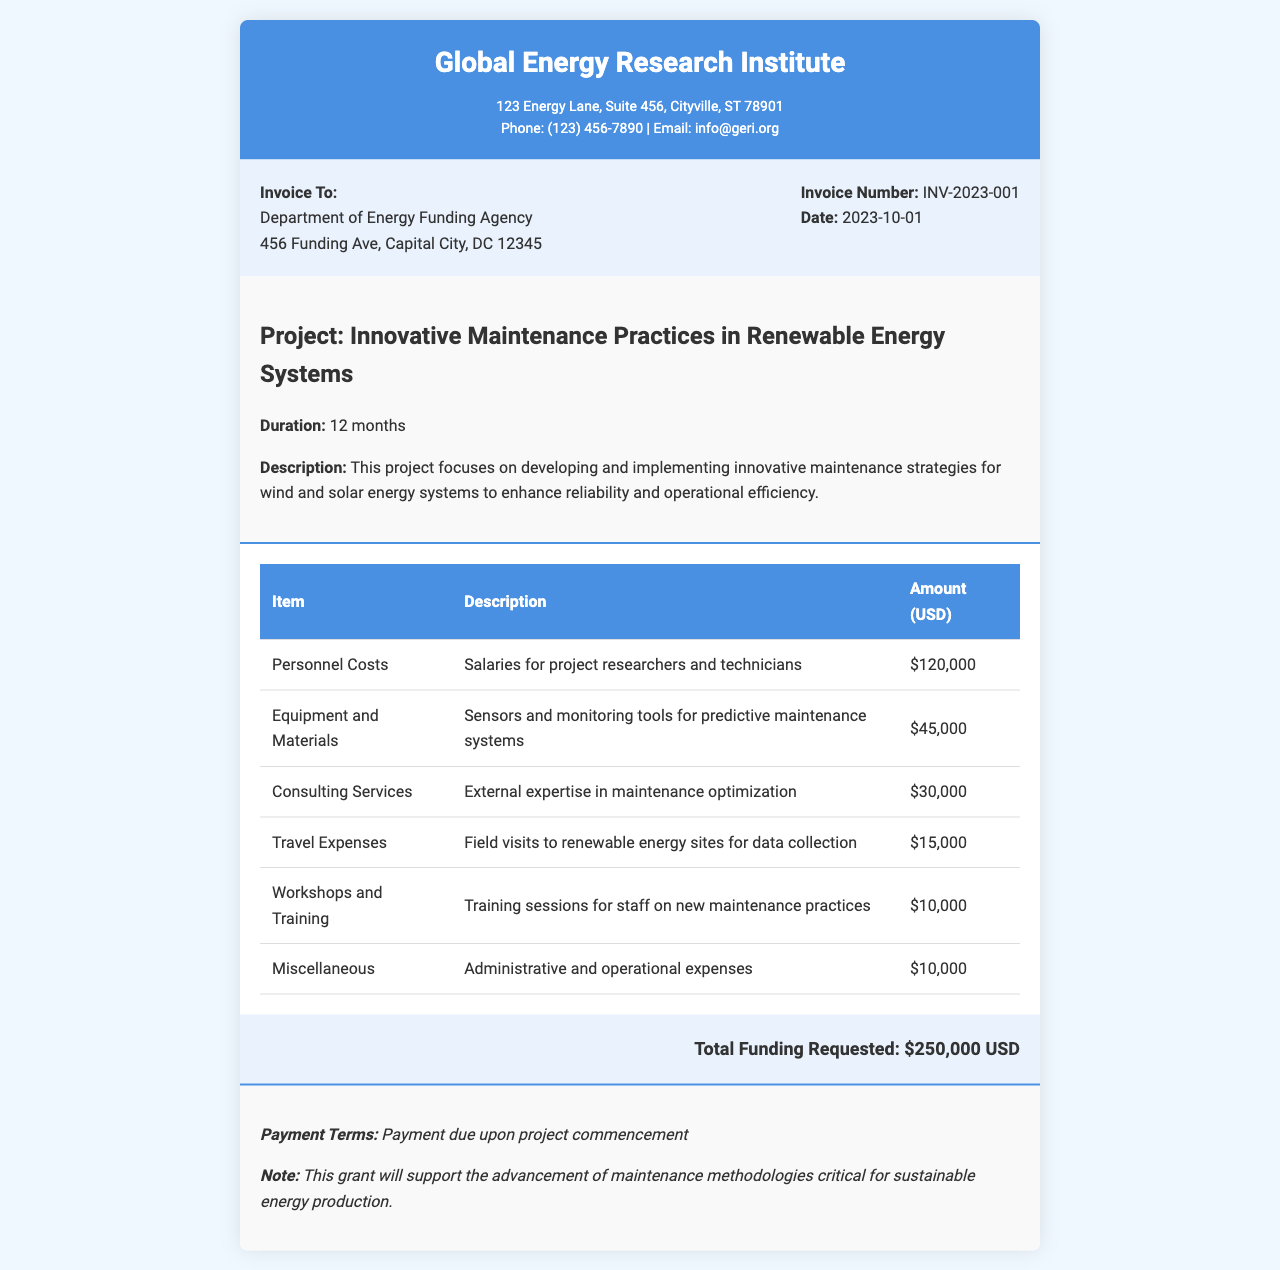What is the organization issuing the invoice? The header of the document provides the name of the organization, which is the Global Energy Research Institute.
Answer: Global Energy Research Institute What is the total funding requested? The total amount is highlighted in the invoice section and is the sum of all expenses listed.
Answer: $250,000 USD Who is the invoice addressed to? The document specifies the recipient under "Invoice To," which identifies the Department of Energy Funding Agency.
Answer: Department of Energy Funding Agency What is the date of the invoice? The date is mentioned in the invoice details section and indicates when the invoice was issued.
Answer: 2023-10-01 What is the duration of the project? The project details section specifies the timeframe for the project as stated in the document.
Answer: 12 months How much is allocated for travel expenses? Travel expenses are listed as one of the itemized costs, providing a specific amount in the expenses table.
Answer: $15,000 What is the purpose of the consulting services? The expenses table includes a brief description of consulting services, explaining their role in the project.
Answer: External expertise in maintenance optimization What are the payment terms? The notes section specifies the payment conditions related to the grant and project initiation.
Answer: Payment due upon project commencement What type of project is detailed in the invoice? The project description provides insights into the nature of the work being funded by the grant.
Answer: Innovative Maintenance Practices in Renewable Energy Systems 